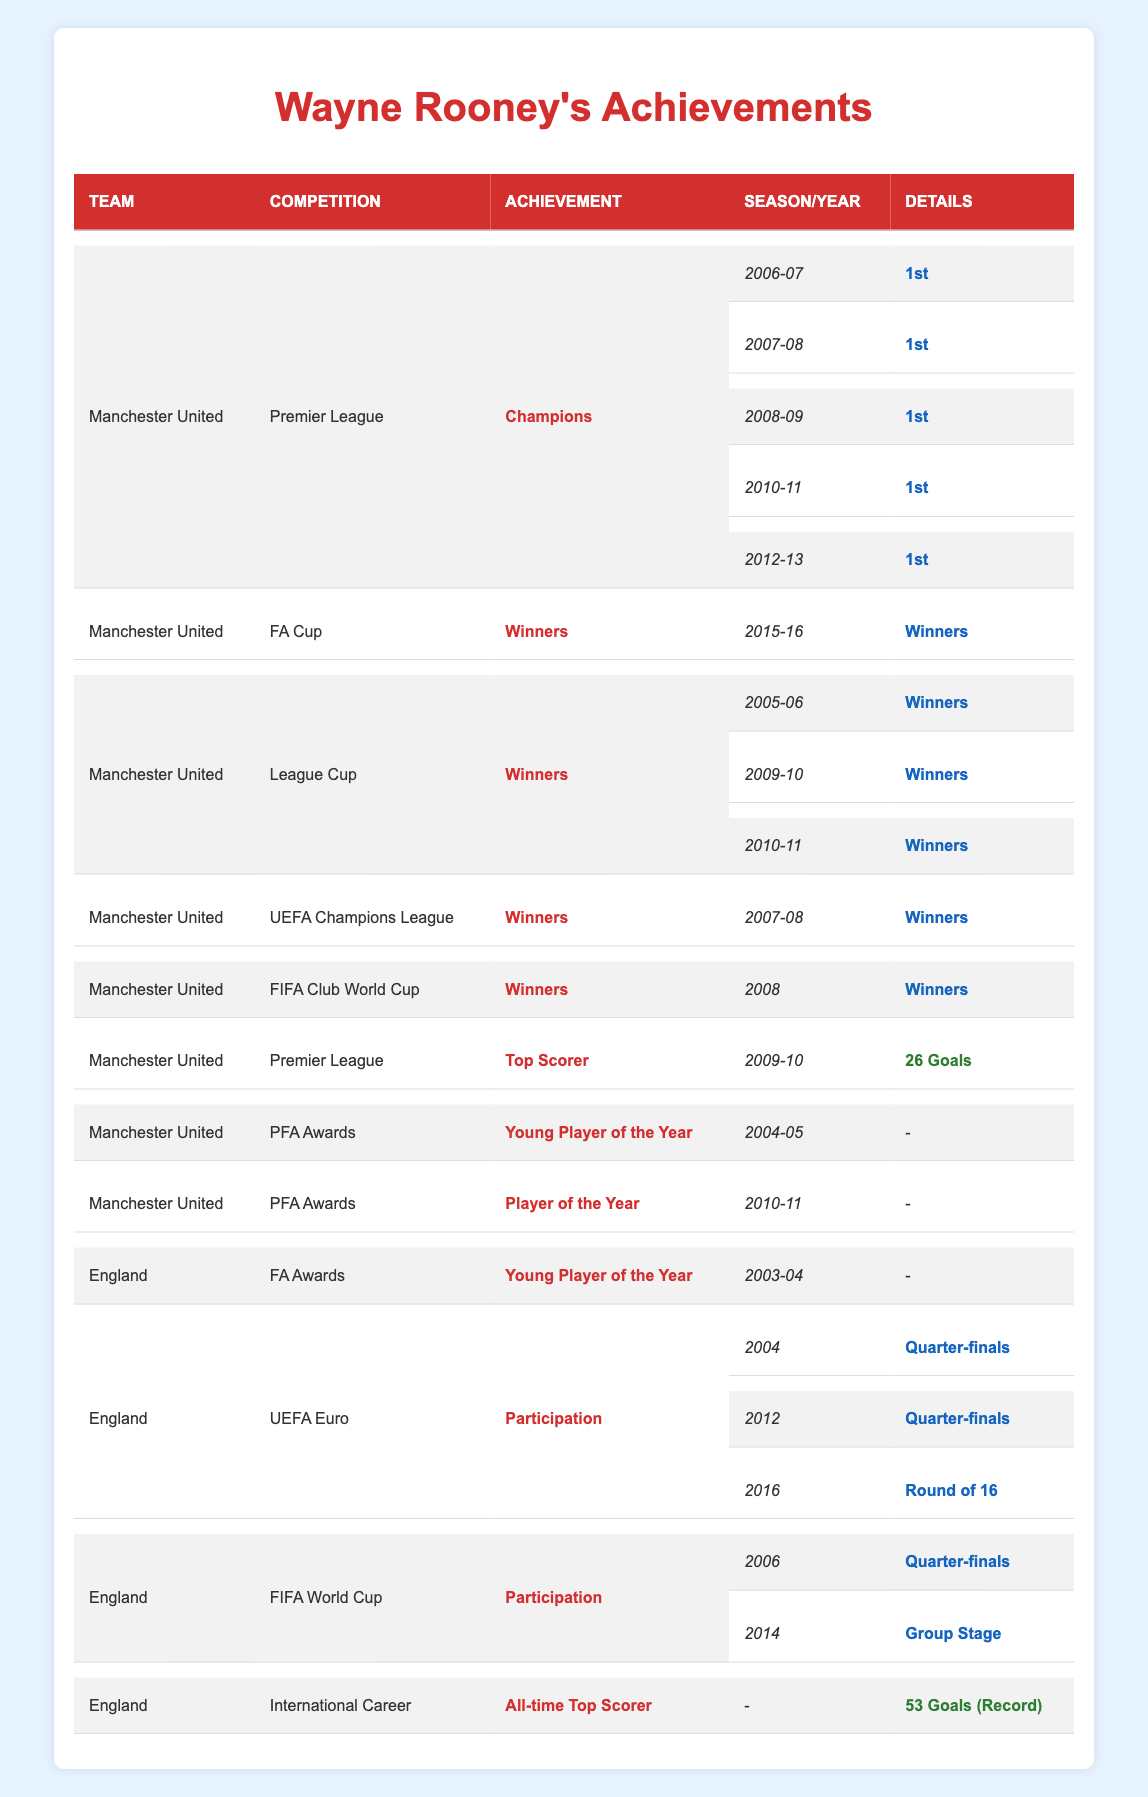What Premier League titles did Wayne Rooney win with Manchester United? Rooney won Premier League titles in the following seasons: 2006-07, 2007-08, 2008-09, 2010-11, and 2012-13.
Answer: 5 titles Which domestic cups did Wayne Rooney win with Manchester United? Rooney won the FA Cup in 2015-16 and the League Cup in 2005-06, 2009-10, and 2010-11.
Answer: FA Cup and 3 League Cups How many times did Rooney score 26 goals as a Premier League Top Scorer? According to the table, Rooney was the Premier League Top Scorer with 26 goals only in the 2009-10 season.
Answer: 1 time Did Wayne Rooney win the PFA Player of the Year award? Yes, the table indicates that he won the PFA Player of the Year award in the 2010-11 season.
Answer: Yes What was Wayne Rooney's highest achievement with England in the UEFA Euro tournaments? Rooney reached the quarter-finals in the UEFA Euro tournaments of 2004 and 2012.
Answer: Quarter-finals How many goals did Wayne Rooney score in total for the England national team? The table notes that Rooney scored 53 goals for the England national team, making him the all-time top scorer.
Answer: 53 goals What seasons did Rooney win the League Cup with Manchester United? Rooney won the League Cup in the 2005-06, 2009-10, and 2010-11 seasons according to the data.
Answer: 2005-06, 2009-10, 2010-11 What was Rooney's position in the FIFA World Cup of 2006? The table shows that Rooney's England team reached the quarter-finals in the 2006 FIFA World Cup.
Answer: Quarter-finals Which year did Wayne Rooney receive the FA Young Player of the Year award? Rooney received the FA Young Player of the Year award in the 2003-04 season, as noted in the table.
Answer: 2003-04 Did Wayne Rooney ever win the UEFA Champions League with Manchester United? Yes, he won the UEFA Champions League in the 2007-08 season.
Answer: Yes How many runners-up positions did Rooney have in the UEFA Euro tournaments? Rooney did not reach the finals in any UEFA Euro tournaments listed, as the highest positions were quarter-finals and round of 16.
Answer: 0 runners-up What was the highest position Rooney achieved in UEFA Euro tournaments? Rooney's highest positions in UEFA Euro tournaments were quarter-finals in 2004 and 2012.
Answer: Quarter-finals 